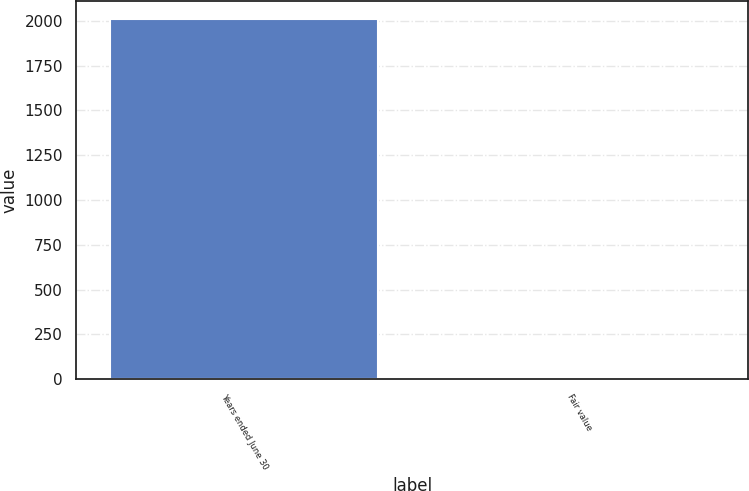<chart> <loc_0><loc_0><loc_500><loc_500><bar_chart><fcel>Years ended June 30<fcel>Fair value<nl><fcel>2011<fcel>7.59<nl></chart> 